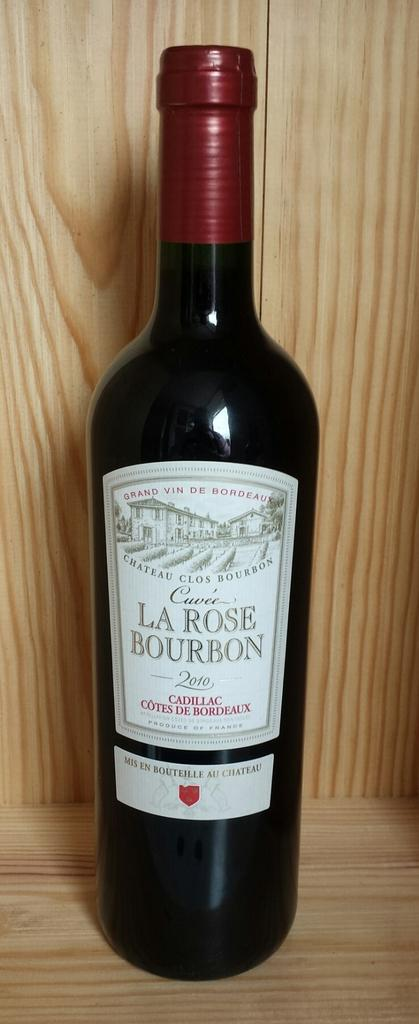<image>
Give a short and clear explanation of the subsequent image. a bottle of La Rose Bourbon sits in a wooden case 